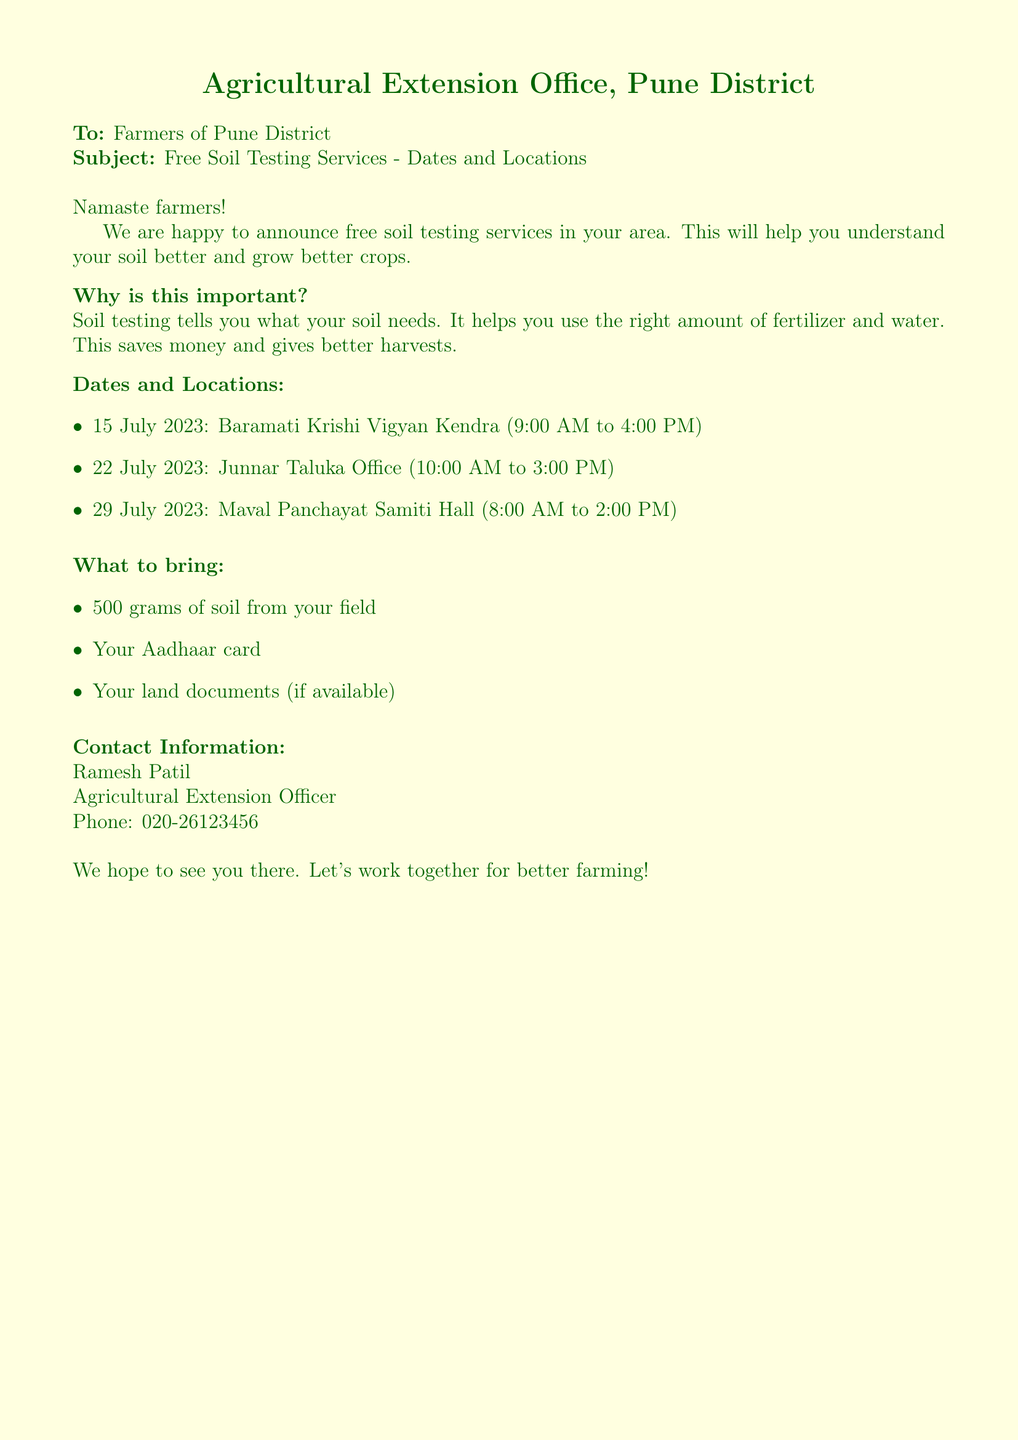what is the name of the office sending the fax? The fax is sent by the Agricultural Extension Office located in Pune District.
Answer: Agricultural Extension Office, Pune District what are the dates for soil testing? The dates for soil testing mentioned in the document are 15 July 2023, 22 July 2023, and 29 July 2023.
Answer: 15 July 2023, 22 July 2023, 29 July 2023 where will the soil testing on 22 July 2023 take place? The location for soil testing on this date is the Junnar Taluka Office.
Answer: Junnar Taluka Office what should farmers bring for soil testing? The document lists three items that farmers should bring: 500 grams of soil, an Aadhaar card, and land documents if available.
Answer: 500 grams of soil, Aadhaar card, land documents who is the contact person listed in the document? The document mentions Ramesh Patil as the contact person for further inquiries regarding the soil testing services.
Answer: Ramesh Patil what is the time for soil testing on 29 July 2023? The document states that soil testing on this date will occur from 8:00 AM to 2:00 PM.
Answer: 8:00 AM to 2:00 PM why is soil testing important according to the document? The document explains that soil testing helps understand soil needs, enabling farmers to use the right amount of fertilizer and water, which leads to savings and better harvests.
Answer: Understand soil needs what is the main purpose of the fax? The main purpose of the fax is to announce free soil testing services for farmers in Pune District.
Answer: Announce free soil testing services what is the phone number for the contact person? The document provides the phone number for Ramesh Patil as 020-26123456.
Answer: 020-26123456 